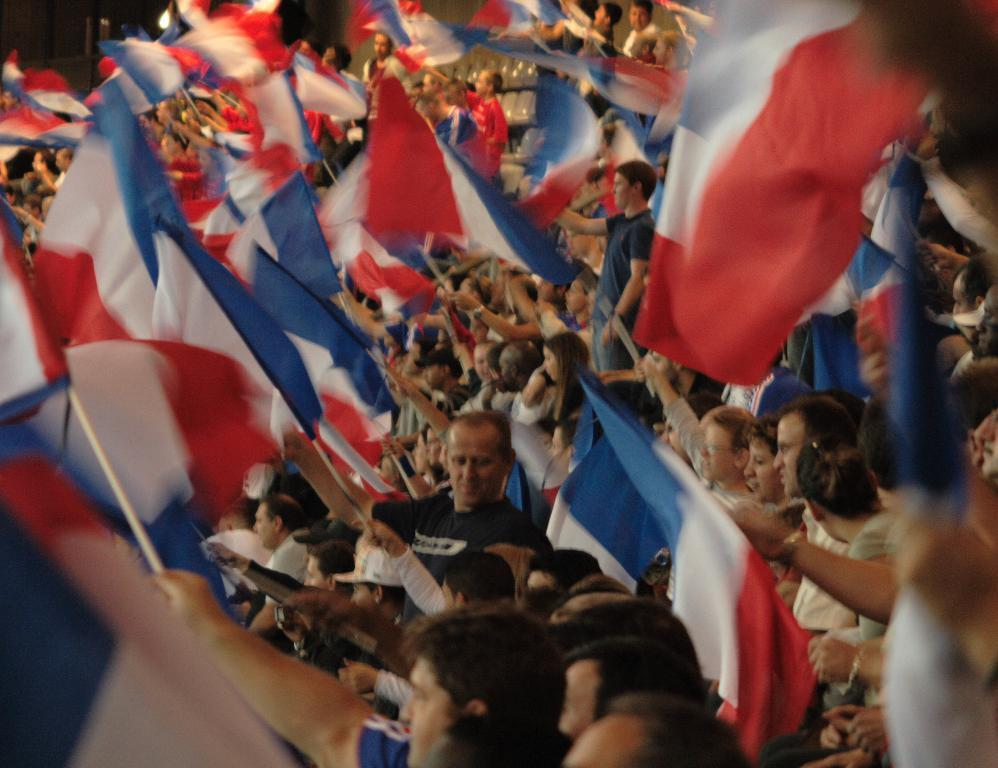What is happening in the image involving a group of people? There is a group of people in the image, and they are holding a flag. What are the people doing with the flag? The people are waving the flag. What type of ball is being used by the people in the image? There is no ball present in the image; the people are holding and waving a flag. 